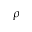<formula> <loc_0><loc_0><loc_500><loc_500>\rho</formula> 